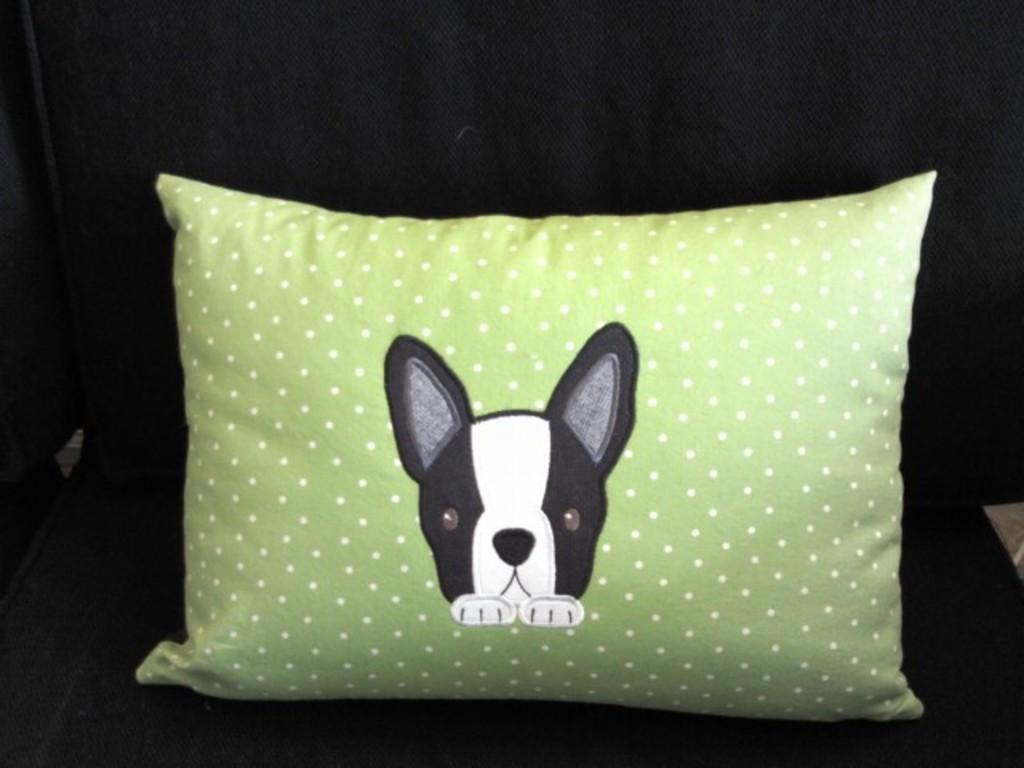What object can be seen in the image? There is a pillow in the image. What is the color of the pillow? The pillow is green in color. How many spiders are crawling on the pillow in the image? There are no spiders visible on the pillow in the image. What type of hearing aid is being used by the pillow in the image? The pillow does not have any hearing aids, as it is an inanimate object. 